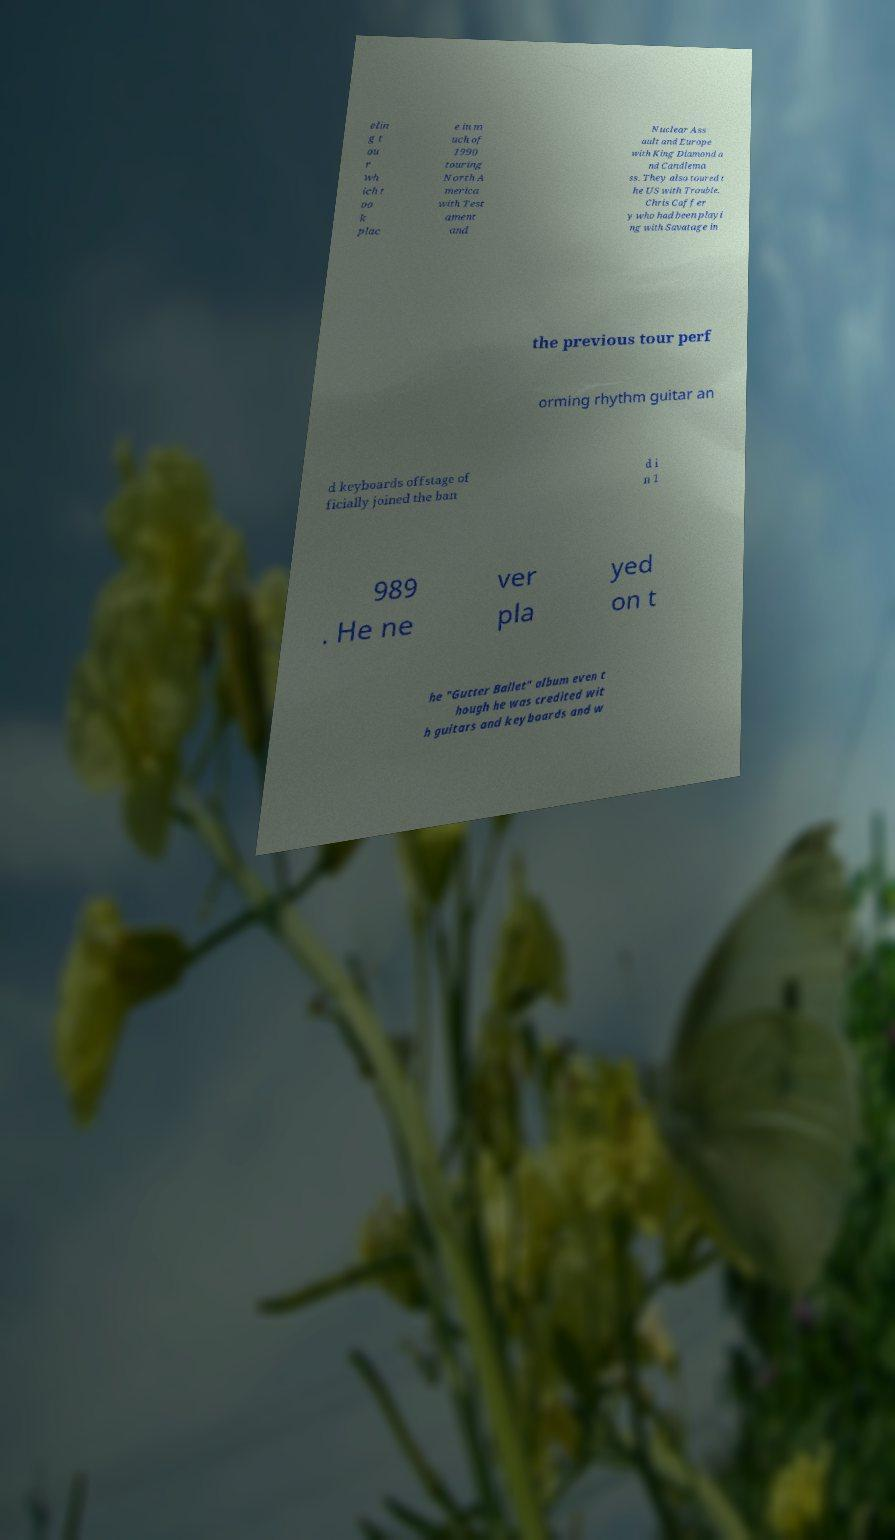There's text embedded in this image that I need extracted. Can you transcribe it verbatim? elin g t ou r wh ich t oo k plac e in m uch of 1990 touring North A merica with Test ament and Nuclear Ass ault and Europe with King Diamond a nd Candlema ss. They also toured t he US with Trouble. Chris Caffer y who had been playi ng with Savatage in the previous tour perf orming rhythm guitar an d keyboards offstage of ficially joined the ban d i n 1 989 . He ne ver pla yed on t he "Gutter Ballet" album even t hough he was credited wit h guitars and keyboards and w 